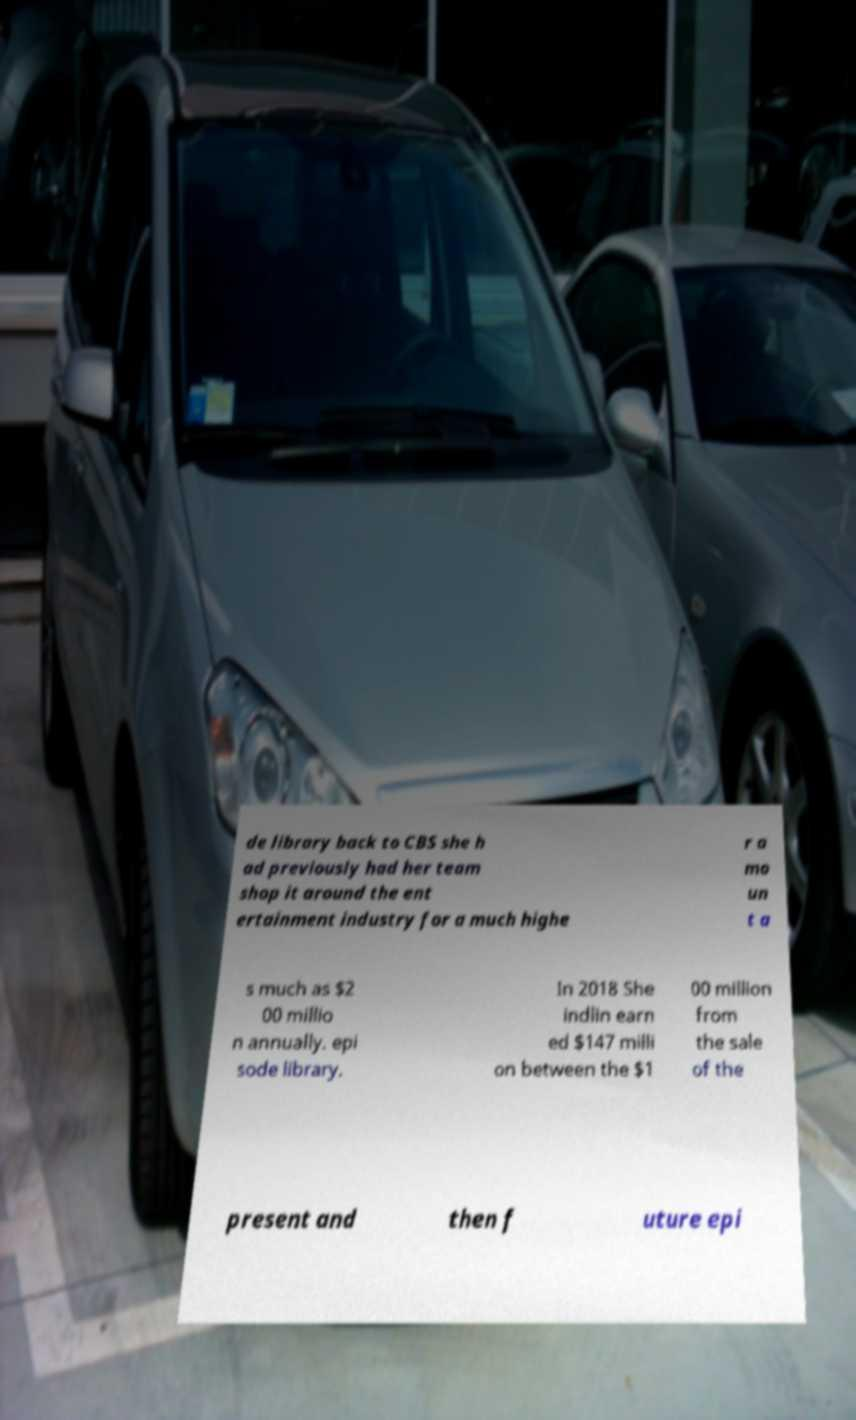Please identify and transcribe the text found in this image. de library back to CBS she h ad previously had her team shop it around the ent ertainment industry for a much highe r a mo un t a s much as $2 00 millio n annually. epi sode library. In 2018 She indlin earn ed $147 milli on between the $1 00 million from the sale of the present and then f uture epi 